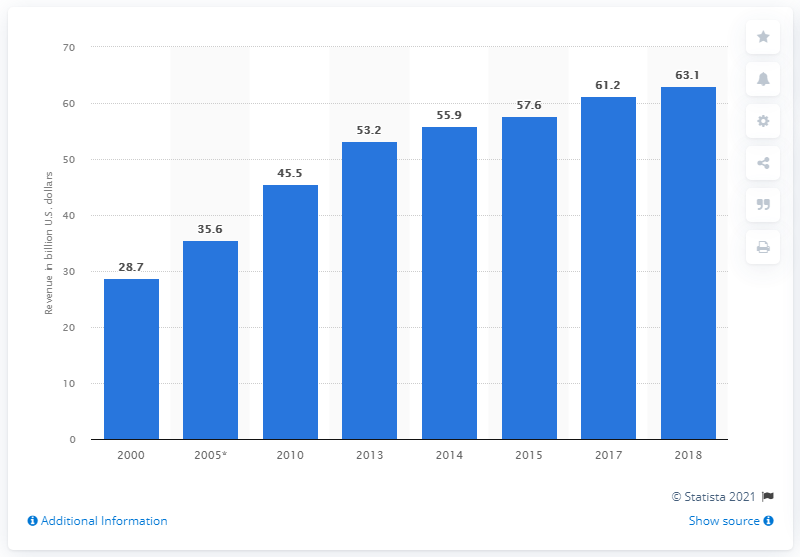Indicate a few pertinent items in this graphic. In 2018, the revenues generated from wastewater treatment in the United States totaled $63.1 million. 